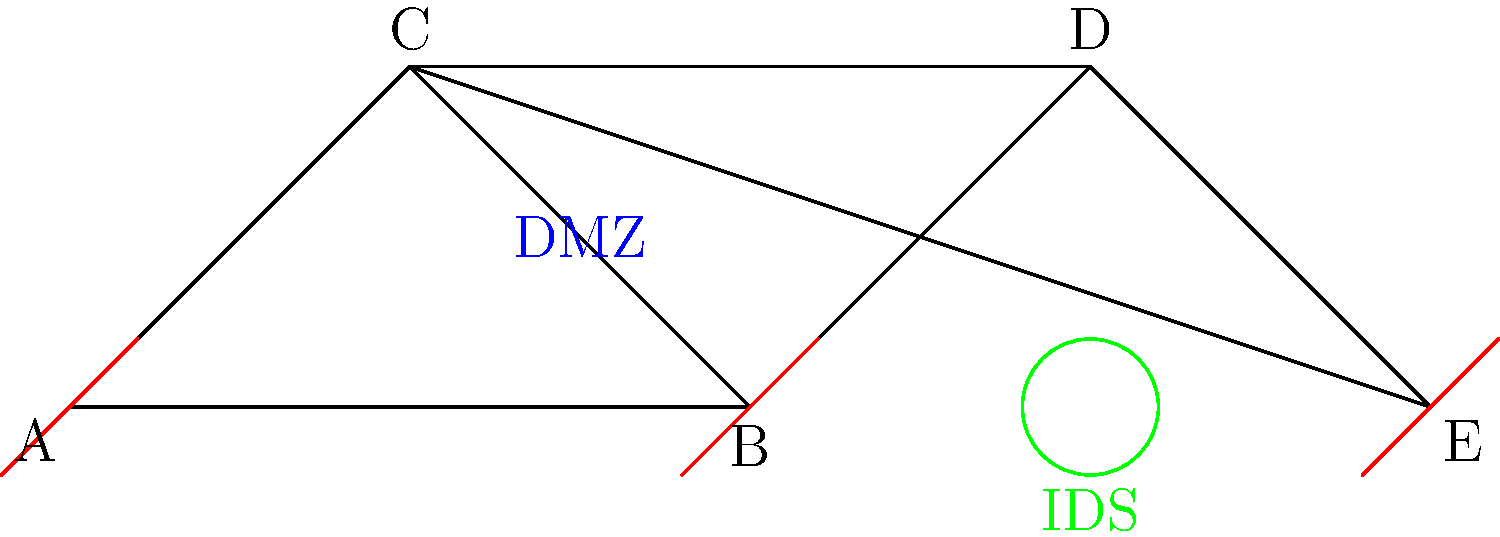In the network topology diagram shown, which cybersecurity implementation is represented by the green circle, and what is its primary function in relation to the DMZ? To answer this question, let's analyze the network topology diagram step-by-step:

1. The diagram shows a network with 5 nodes (A, B, C, D, and E) connected in a specific topology.

2. There are red symbols at nodes A, B, and E, which typically represent firewalls in network diagrams.

3. The area between nodes B, C, and D is labeled "DMZ" (Demilitarized Zone), which is a network segment that acts as a buffer between the internal network and the external, untrusted network (usually the internet).

4. There is a green circle near node D, labeled "IDS".

5. IDS stands for Intrusion Detection System, which is a device or software application that monitors network traffic for suspicious activity and policy violations.

6. The primary function of an IDS in relation to the DMZ is to monitor traffic entering and leaving the DMZ for any signs of malicious activity or security breaches.

7. By placing the IDS near the DMZ, it can detect potential threats before they reach the internal network, providing an additional layer of security beyond the firewalls.

Therefore, the green circle represents an Intrusion Detection System (IDS), and its primary function in relation to the DMZ is to monitor network traffic for potential security threats and unauthorized access attempts.
Answer: Intrusion Detection System (IDS); monitors DMZ traffic for security threats 